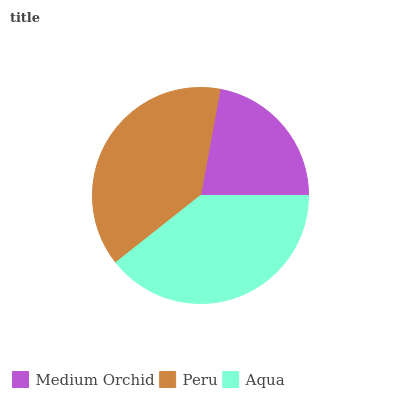Is Medium Orchid the minimum?
Answer yes or no. Yes. Is Aqua the maximum?
Answer yes or no. Yes. Is Peru the minimum?
Answer yes or no. No. Is Peru the maximum?
Answer yes or no. No. Is Peru greater than Medium Orchid?
Answer yes or no. Yes. Is Medium Orchid less than Peru?
Answer yes or no. Yes. Is Medium Orchid greater than Peru?
Answer yes or no. No. Is Peru less than Medium Orchid?
Answer yes or no. No. Is Peru the high median?
Answer yes or no. Yes. Is Peru the low median?
Answer yes or no. Yes. Is Aqua the high median?
Answer yes or no. No. Is Aqua the low median?
Answer yes or no. No. 